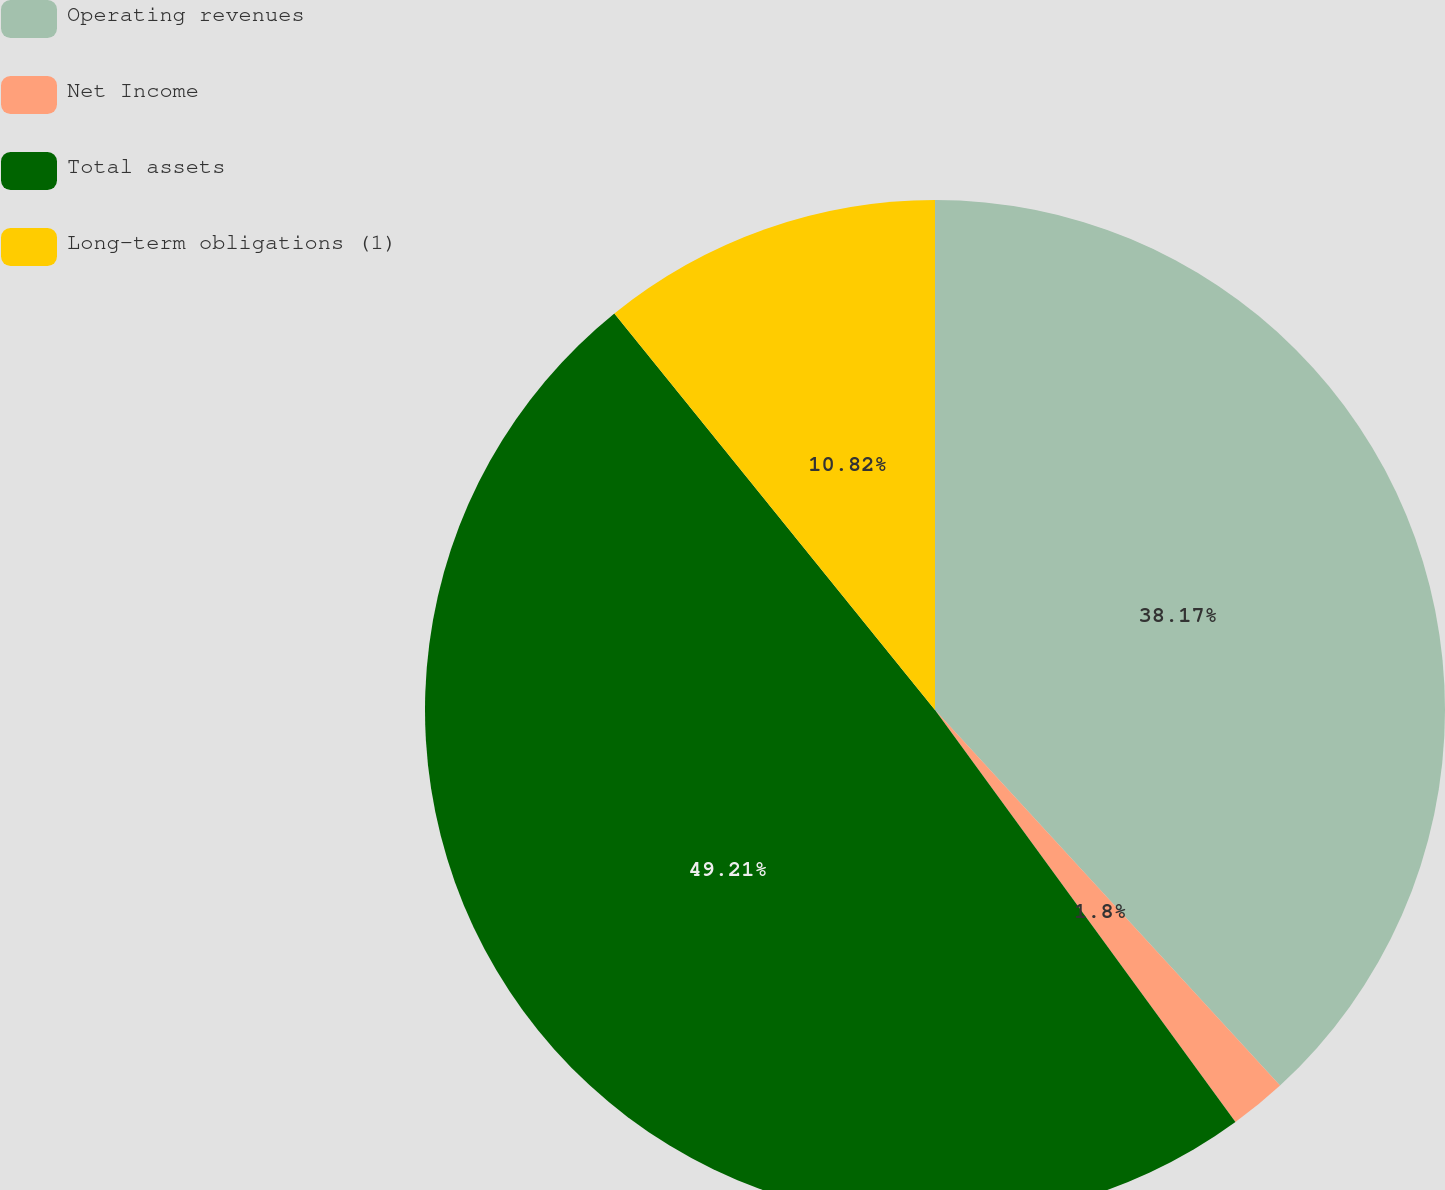Convert chart to OTSL. <chart><loc_0><loc_0><loc_500><loc_500><pie_chart><fcel>Operating revenues<fcel>Net Income<fcel>Total assets<fcel>Long-term obligations (1)<nl><fcel>38.17%<fcel>1.8%<fcel>49.2%<fcel>10.82%<nl></chart> 